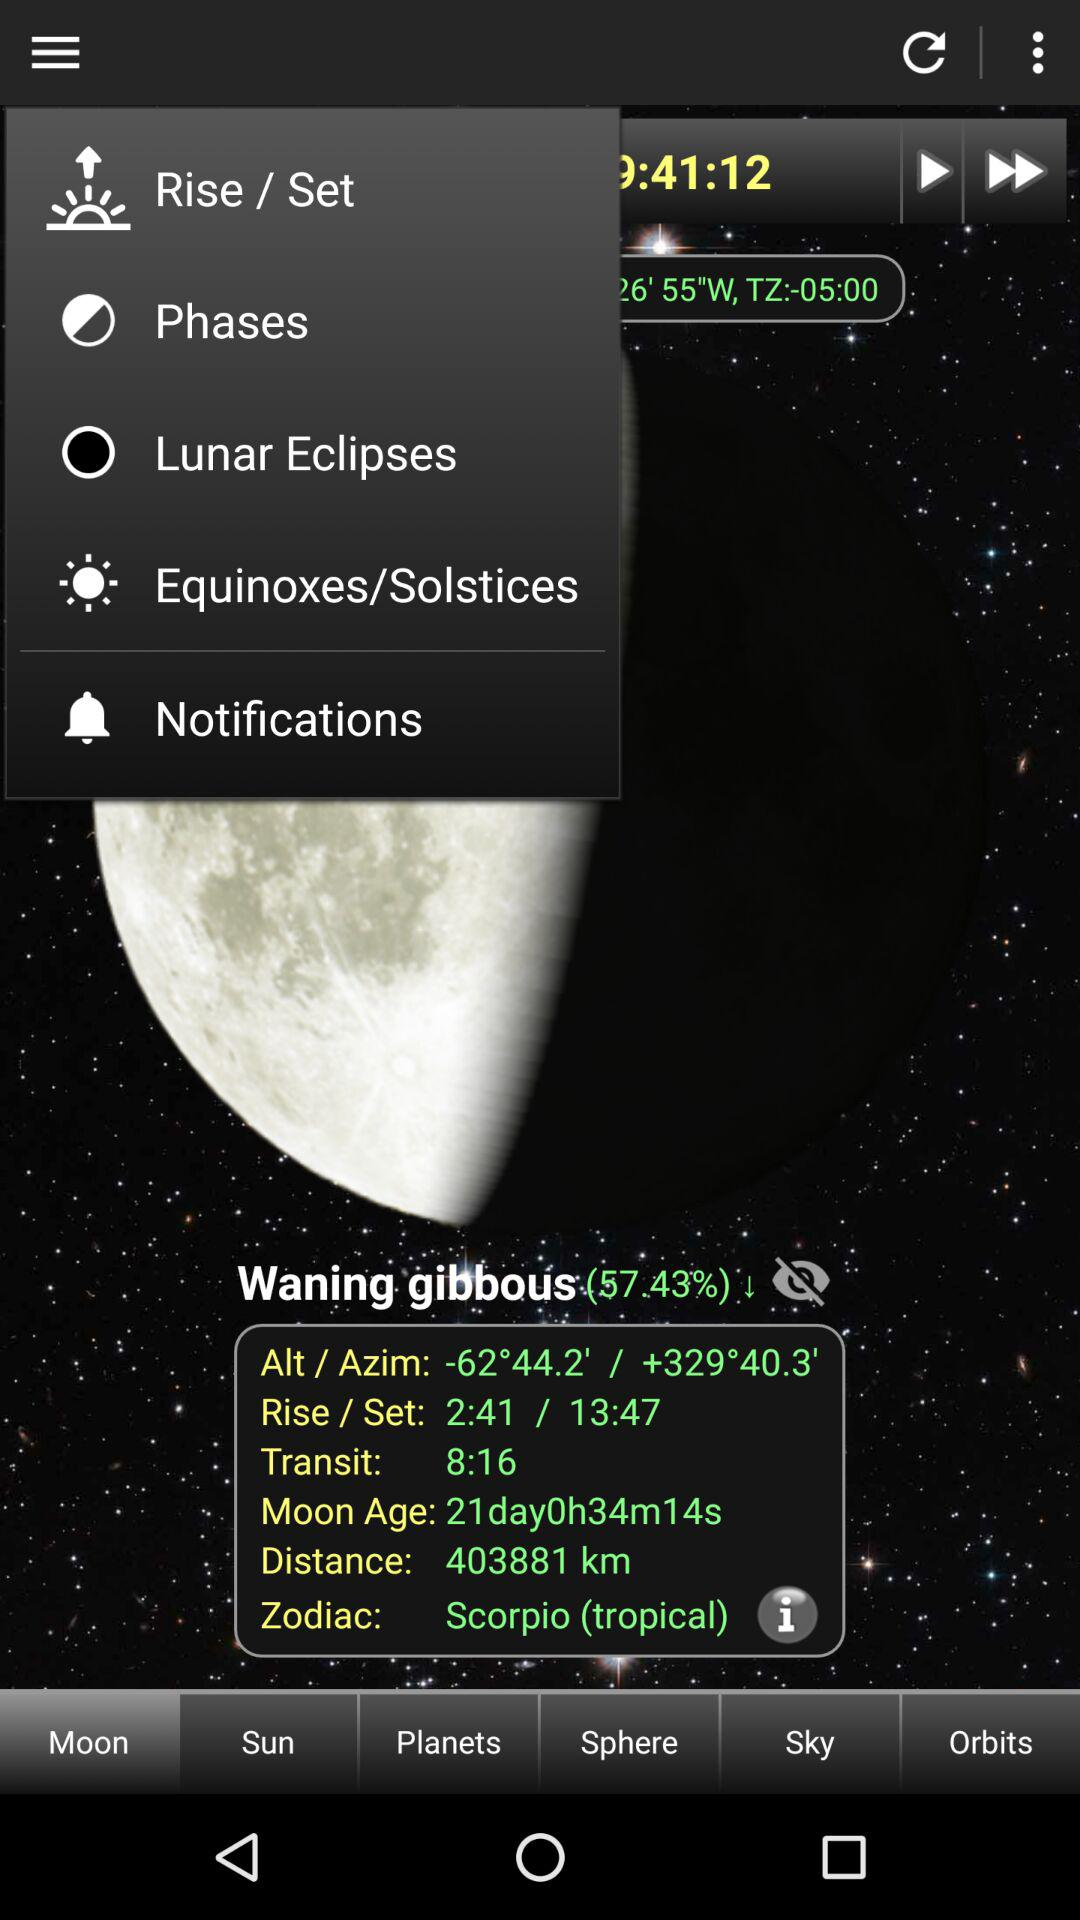Which tab has been selected? The selected tab is "Moon". 